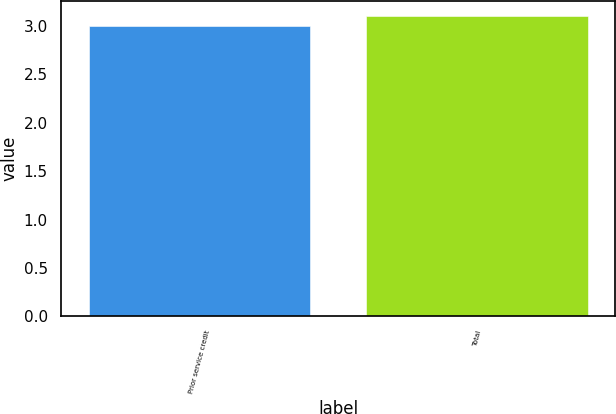<chart> <loc_0><loc_0><loc_500><loc_500><bar_chart><fcel>Prior service credit<fcel>Total<nl><fcel>3<fcel>3.1<nl></chart> 